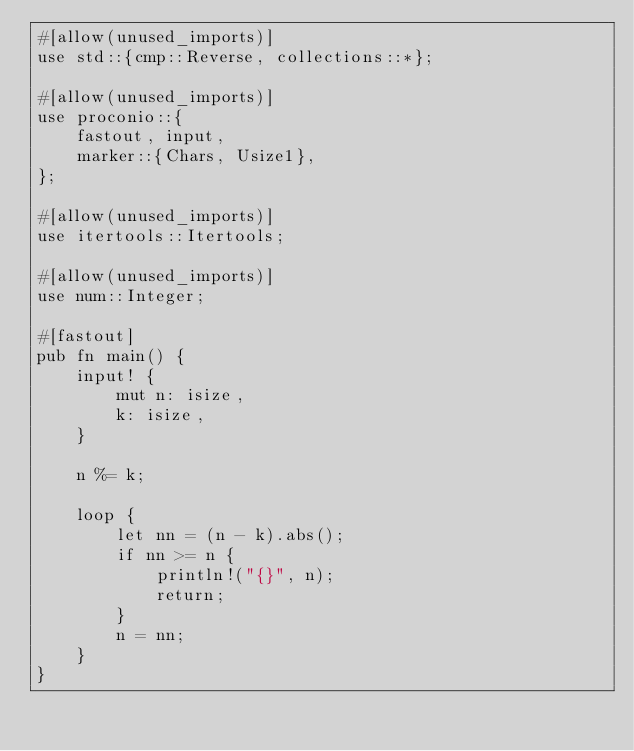Convert code to text. <code><loc_0><loc_0><loc_500><loc_500><_Rust_>#[allow(unused_imports)]
use std::{cmp::Reverse, collections::*};

#[allow(unused_imports)]
use proconio::{
    fastout, input,
    marker::{Chars, Usize1},
};

#[allow(unused_imports)]
use itertools::Itertools;

#[allow(unused_imports)]
use num::Integer;

#[fastout]
pub fn main() {
    input! {
        mut n: isize,
        k: isize,
    }

    n %= k;

    loop {
        let nn = (n - k).abs();
        if nn >= n {
            println!("{}", n);
            return;
        }
        n = nn;
    }
}
</code> 